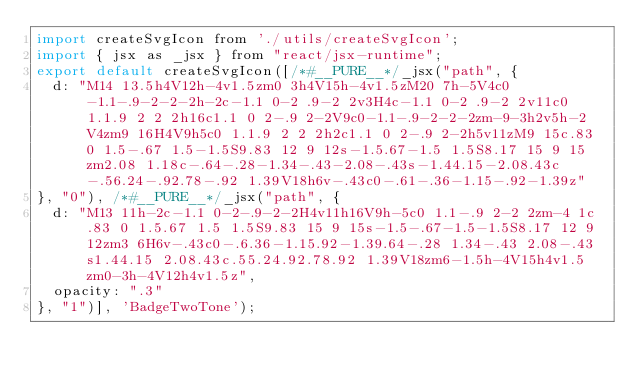<code> <loc_0><loc_0><loc_500><loc_500><_JavaScript_>import createSvgIcon from './utils/createSvgIcon';
import { jsx as _jsx } from "react/jsx-runtime";
export default createSvgIcon([/*#__PURE__*/_jsx("path", {
  d: "M14 13.5h4V12h-4v1.5zm0 3h4V15h-4v1.5zM20 7h-5V4c0-1.1-.9-2-2-2h-2c-1.1 0-2 .9-2 2v3H4c-1.1 0-2 .9-2 2v11c0 1.1.9 2 2 2h16c1.1 0 2-.9 2-2V9c0-1.1-.9-2-2-2zm-9-3h2v5h-2V4zm9 16H4V9h5c0 1.1.9 2 2 2h2c1.1 0 2-.9 2-2h5v11zM9 15c.83 0 1.5-.67 1.5-1.5S9.83 12 9 12s-1.5.67-1.5 1.5S8.17 15 9 15zm2.08 1.18c-.64-.28-1.34-.43-2.08-.43s-1.44.15-2.08.43c-.56.24-.92.78-.92 1.39V18h6v-.43c0-.61-.36-1.15-.92-1.39z"
}, "0"), /*#__PURE__*/_jsx("path", {
  d: "M13 11h-2c-1.1 0-2-.9-2-2H4v11h16V9h-5c0 1.1-.9 2-2 2zm-4 1c.83 0 1.5.67 1.5 1.5S9.83 15 9 15s-1.5-.67-1.5-1.5S8.17 12 9 12zm3 6H6v-.43c0-.6.36-1.15.92-1.39.64-.28 1.34-.43 2.08-.43s1.44.15 2.08.43c.55.24.92.78.92 1.39V18zm6-1.5h-4V15h4v1.5zm0-3h-4V12h4v1.5z",
  opacity: ".3"
}, "1")], 'BadgeTwoTone');</code> 